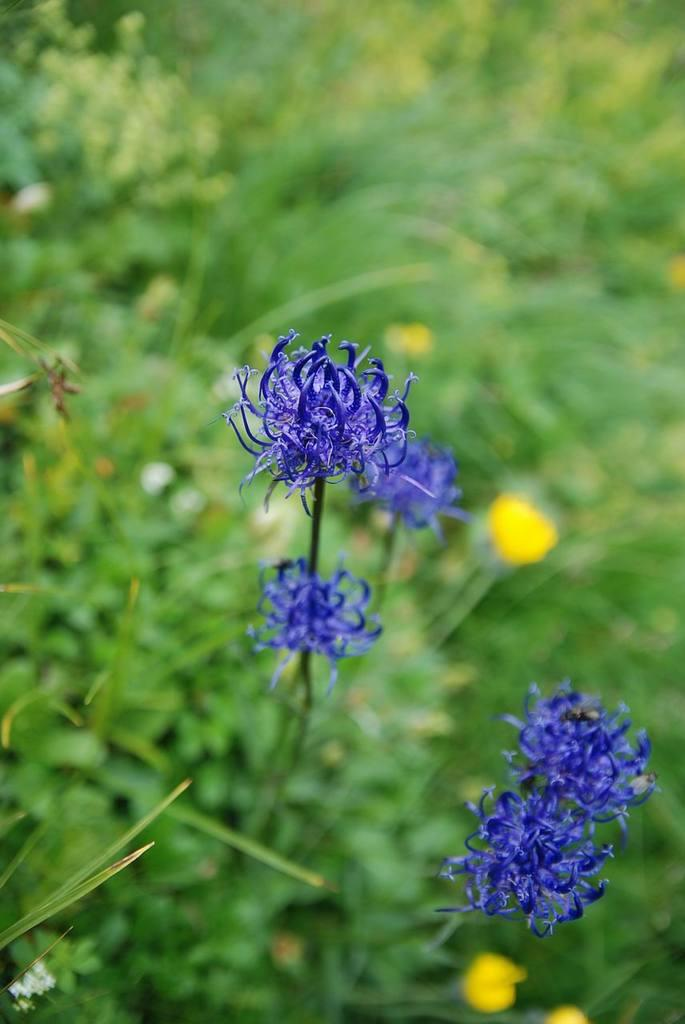What color are the flowers in the image? The flowers in the image are violet. What color is the background in the image? The background in the image is green. What else can be seen in the image besides flowers? There are leaves visible in the image. What other color is present in the image besides green and violet? There are yellow colors present in the image. Can you see an apple in the image? There is no apple present in the image. Is there a wrench visible in the image? There is no wrench present in the image. 